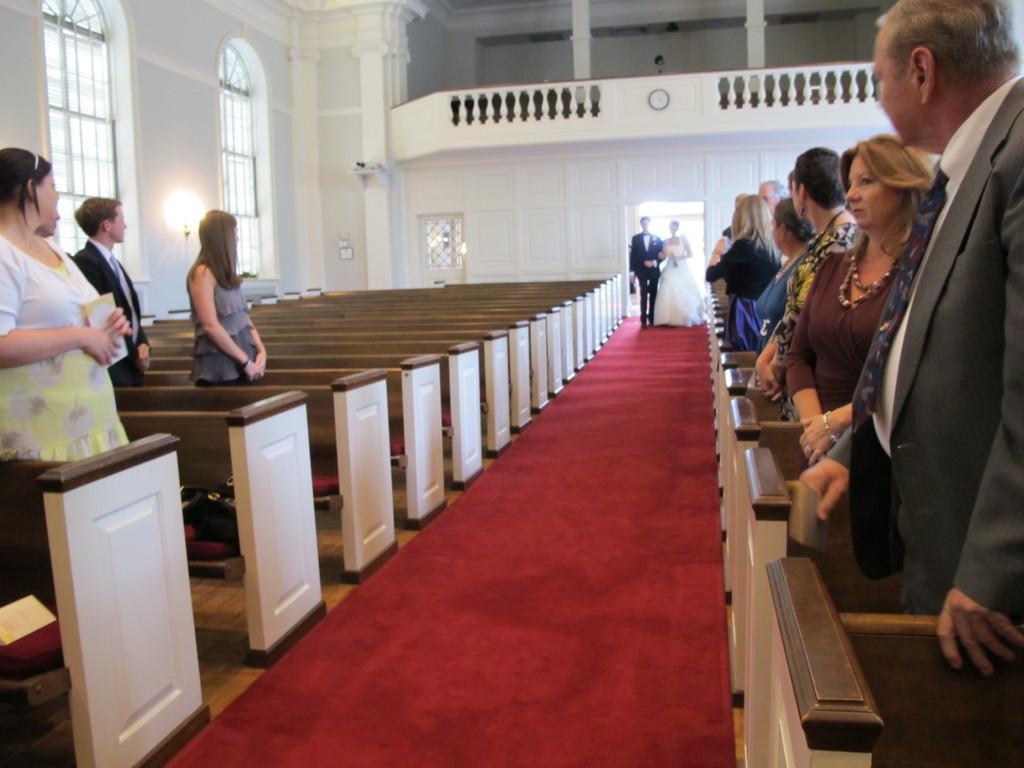Please provide a concise description of this image. In this image we can see a married couple who are walking through the middle, wearing black and white color dress respectively and there are some persons at left and right side of the image standing and at the background of the image there is wall. 